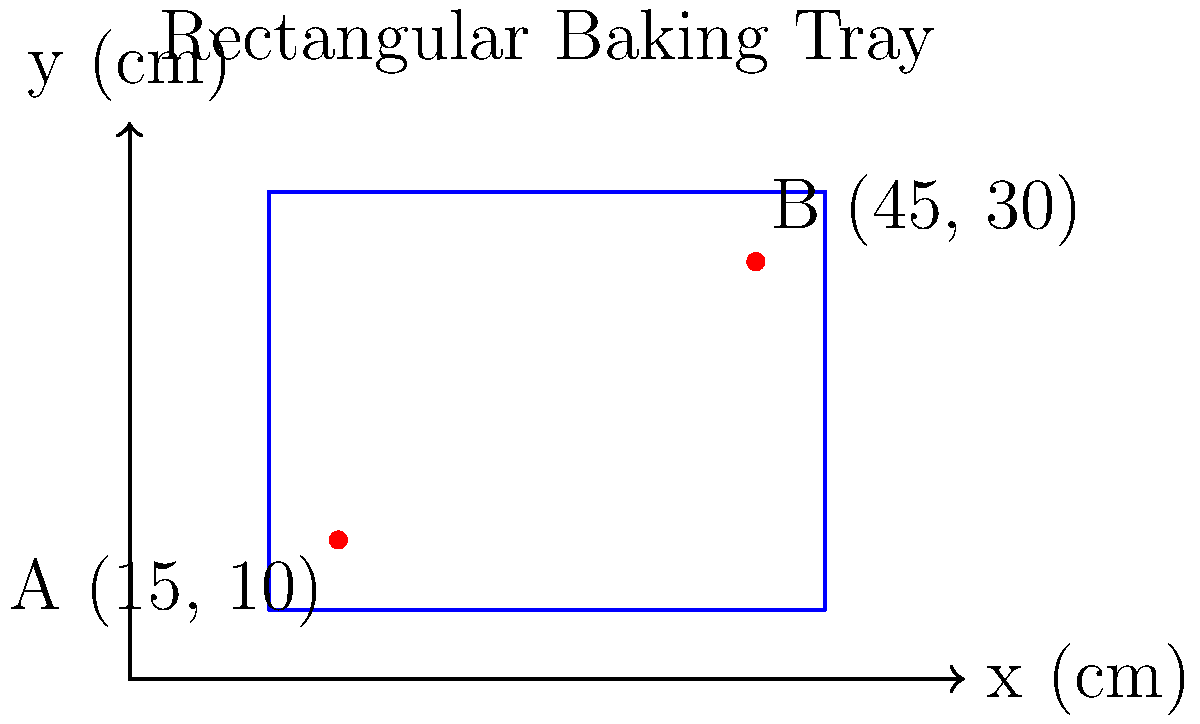On your rectangular baking tray, you've placed two special Viennese pastries at points A(15, 10) and B(45, 30), where coordinates are in centimeters. Calculate the shortest distance between these two pastries on the tray. To find the shortest distance between two points on a coordinate plane, we can use the distance formula, which is derived from the Pythagorean theorem:

$$d = \sqrt{(x_2 - x_1)^2 + (y_2 - y_1)^2}$$

Where $(x_1, y_1)$ are the coordinates of the first point and $(x_2, y_2)$ are the coordinates of the second point.

Let's plug in our values:
Point A: $(x_1, y_1) = (15, 10)$
Point B: $(x_2, y_2) = (45, 30)$

Now, let's calculate:

1) First, find the differences:
   $x_2 - x_1 = 45 - 15 = 30$
   $y_2 - y_1 = 30 - 10 = 20$

2) Square these differences:
   $(x_2 - x_1)^2 = 30^2 = 900$
   $(y_2 - y_1)^2 = 20^2 = 400$

3) Sum the squared differences:
   $900 + 400 = 1300$

4) Take the square root of the sum:
   $d = \sqrt{1300} = 10\sqrt{13} \approx 36.06$ cm

Therefore, the shortest distance between the two pastries is $10\sqrt{13}$ cm or approximately 36.06 cm.
Answer: $10\sqrt{13}$ cm 